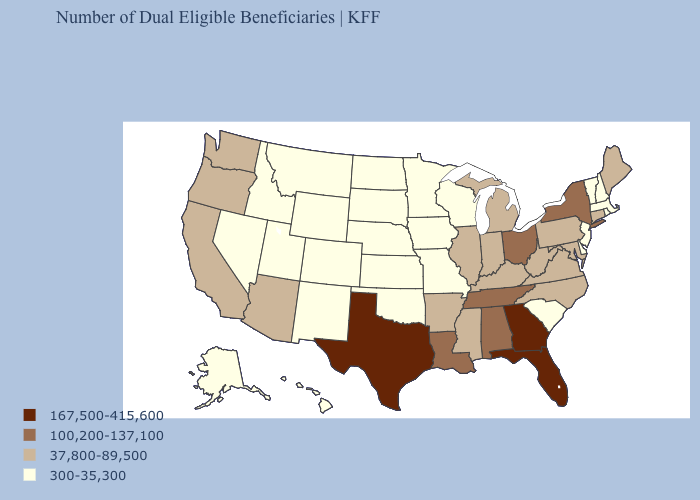Among the states that border Missouri , does Tennessee have the lowest value?
Keep it brief. No. What is the value of Michigan?
Answer briefly. 37,800-89,500. Which states have the lowest value in the Northeast?
Keep it brief. Massachusetts, New Hampshire, New Jersey, Rhode Island, Vermont. What is the value of Nevada?
Short answer required. 300-35,300. Does Maine have a lower value than Tennessee?
Concise answer only. Yes. What is the value of South Dakota?
Give a very brief answer. 300-35,300. What is the value of Ohio?
Quick response, please. 100,200-137,100. Among the states that border New York , which have the highest value?
Short answer required. Connecticut, Pennsylvania. Does Rhode Island have the highest value in the Northeast?
Keep it brief. No. Does the map have missing data?
Keep it brief. No. What is the highest value in the Northeast ?
Concise answer only. 100,200-137,100. Does Delaware have a higher value than Montana?
Give a very brief answer. No. What is the highest value in the South ?
Short answer required. 167,500-415,600. Does South Carolina have the lowest value in the USA?
Keep it brief. Yes. Does Idaho have the same value as Kentucky?
Be succinct. No. 